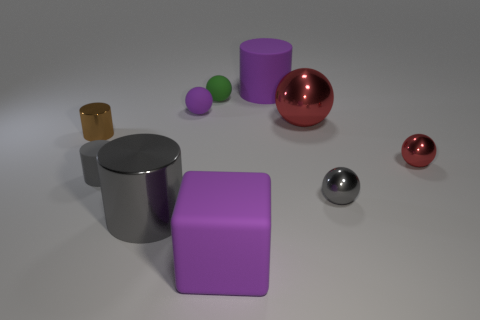Is the number of tiny brown cylinders that are behind the big purple cylinder less than the number of tiny red spheres?
Make the answer very short. Yes. There is a gray object that is in front of the tiny metallic thing that is in front of the matte cylinder in front of the big rubber cylinder; what size is it?
Your answer should be compact. Large. Is the large thing behind the green rubber thing made of the same material as the big red object?
Make the answer very short. No. There is a sphere that is the same color as the big block; what is its material?
Offer a terse response. Rubber. Are there any other things that have the same shape as the brown metallic object?
Your response must be concise. Yes. What number of things are purple cubes or green balls?
Your answer should be compact. 2. There is another gray object that is the same shape as the large gray metallic thing; what size is it?
Keep it short and to the point. Small. Is there any other thing that is the same size as the brown cylinder?
Provide a succinct answer. Yes. What number of other things are there of the same color as the large rubber cylinder?
Keep it short and to the point. 2. What number of blocks are either big green things or brown metal objects?
Make the answer very short. 0. 